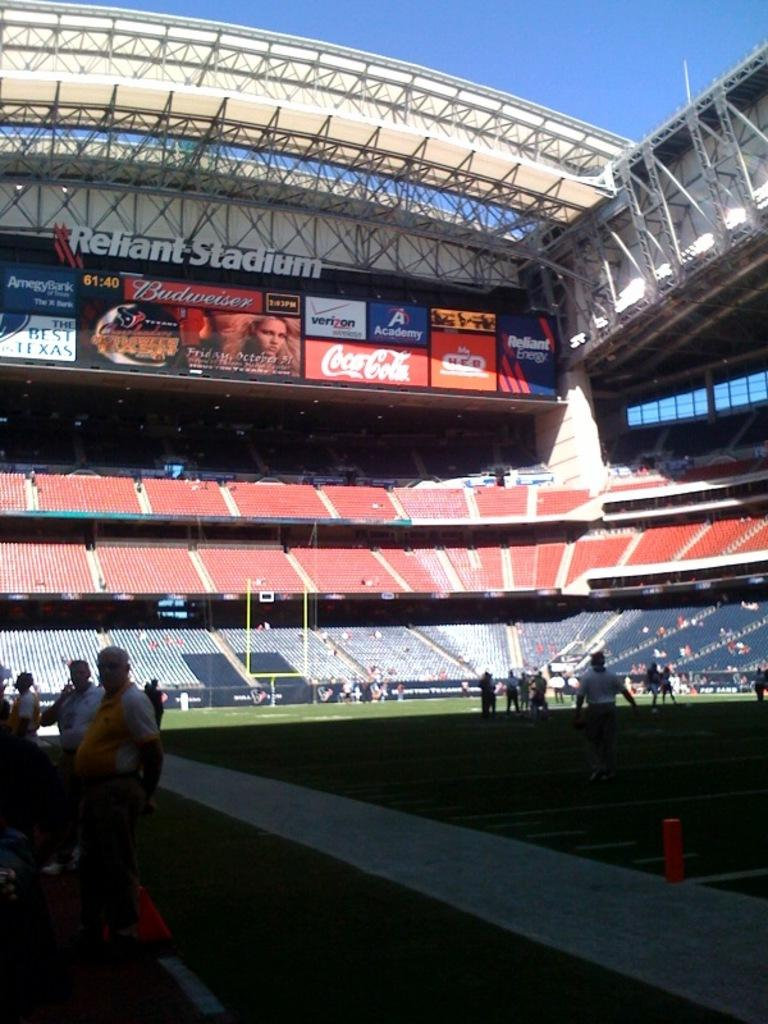<image>
Give a short and clear explanation of the subsequent image. Reliant Football Stadium with different advertisements like Budweiser, Coca Cola, Verizon, and Academy Sports and Outdoors. 